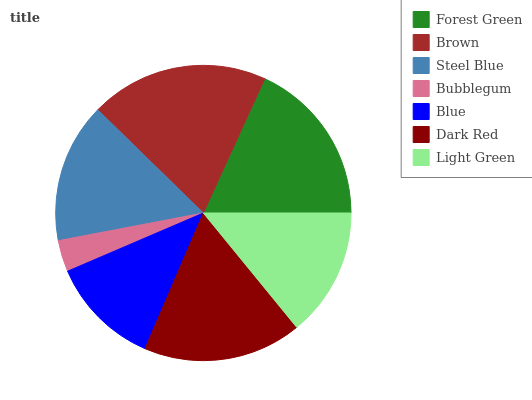Is Bubblegum the minimum?
Answer yes or no. Yes. Is Brown the maximum?
Answer yes or no. Yes. Is Steel Blue the minimum?
Answer yes or no. No. Is Steel Blue the maximum?
Answer yes or no. No. Is Brown greater than Steel Blue?
Answer yes or no. Yes. Is Steel Blue less than Brown?
Answer yes or no. Yes. Is Steel Blue greater than Brown?
Answer yes or no. No. Is Brown less than Steel Blue?
Answer yes or no. No. Is Steel Blue the high median?
Answer yes or no. Yes. Is Steel Blue the low median?
Answer yes or no. Yes. Is Brown the high median?
Answer yes or no. No. Is Blue the low median?
Answer yes or no. No. 